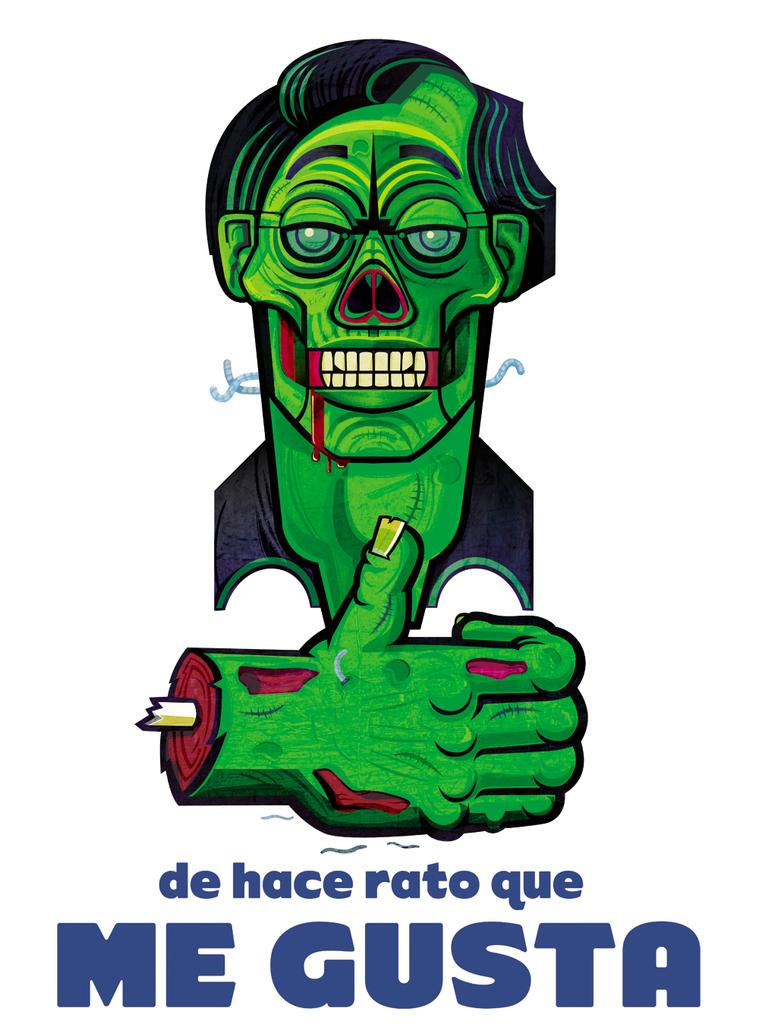<image>
Give a short and clear explanation of the subsequent image. Poster showing a frankenstein and the words "Me Gusta" on the bottom. 